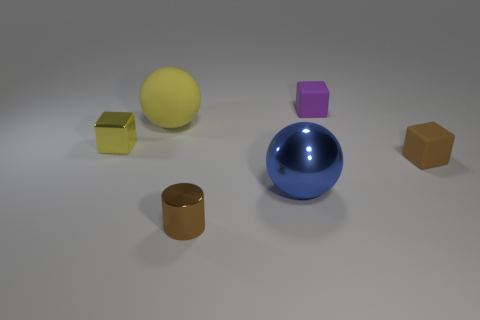Subtract all small rubber cubes. How many cubes are left? 1 Add 1 brown cylinders. How many objects exist? 7 Subtract all purple blocks. How many blocks are left? 2 Add 5 tiny purple objects. How many tiny purple objects exist? 6 Subtract 0 green cylinders. How many objects are left? 6 Subtract all spheres. How many objects are left? 4 Subtract 3 blocks. How many blocks are left? 0 Subtract all brown cubes. Subtract all gray cylinders. How many cubes are left? 2 Subtract all small yellow metallic blocks. Subtract all purple rubber blocks. How many objects are left? 4 Add 4 blue objects. How many blue objects are left? 5 